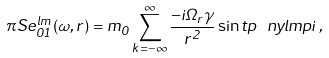<formula> <loc_0><loc_0><loc_500><loc_500>\pi S e ^ { l m } _ { 0 1 } ( \omega , r ) = m _ { 0 } \sum _ { k = - \infty } ^ { \infty } \frac { - i \Omega _ { r } \gamma } { r ^ { 2 } } \sin t p \ n y l m p i \, ,</formula> 